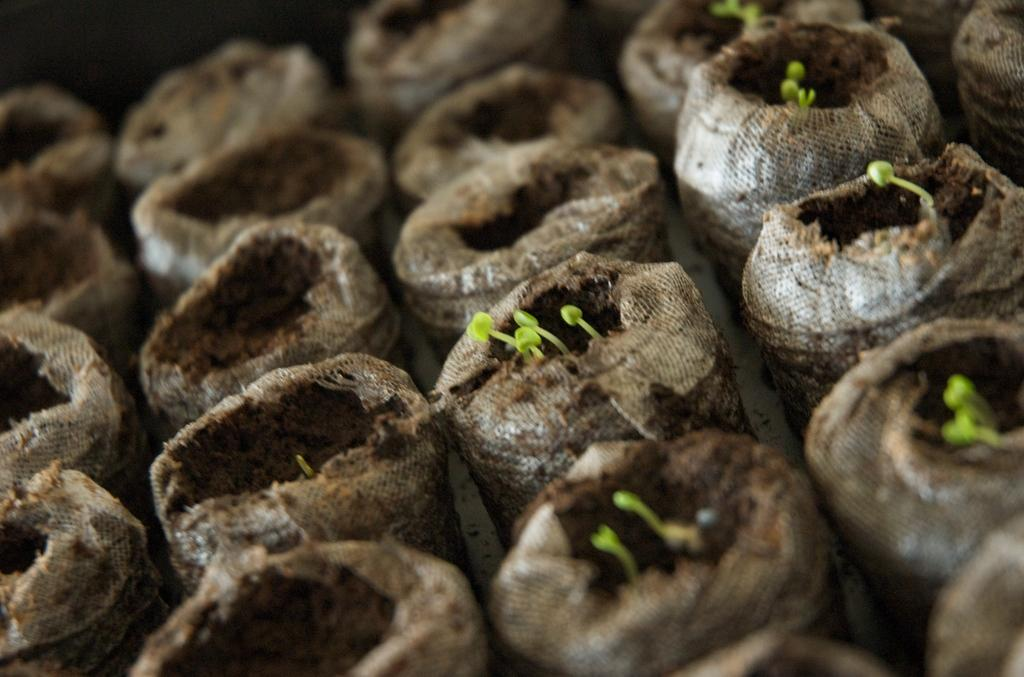What is in the bags that are visible in the image? There are bags with brown colored mud in the image. Are there any plants visible in the bags? Yes, there are green plants in some of the bags. What is the color of the background in the image? The background of the image is black in color. How many pizzas are being kicked by the mom in the image? There are no pizzas or moms present in the image. 